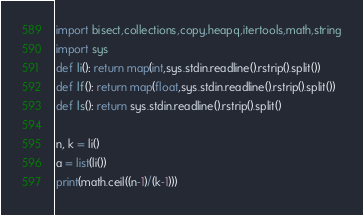Convert code to text. <code><loc_0><loc_0><loc_500><loc_500><_Python_>import bisect,collections,copy,heapq,itertools,math,string
import sys
def li(): return map(int,sys.stdin.readline().rstrip().split())
def lf(): return map(float,sys.stdin.readline().rstrip().split())
def ls(): return sys.stdin.readline().rstrip().split()

n, k = li()
a = list(li())
print(math.ceil((n-1)/(k-1)))</code> 